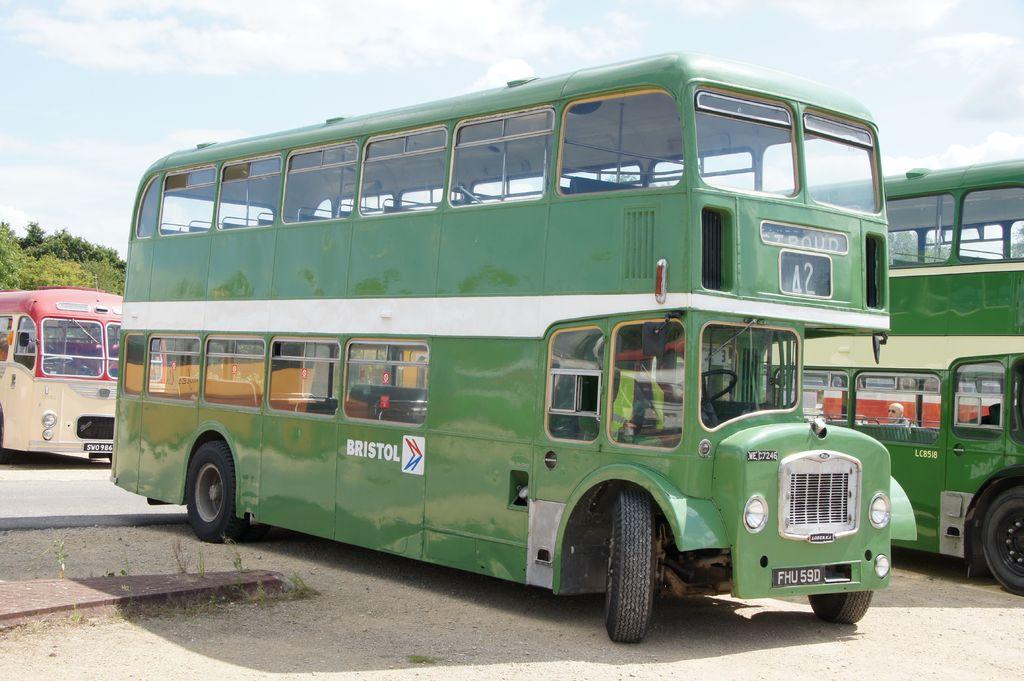What is the license plate number of the green bus?
Your answer should be very brief. Fhu590. 